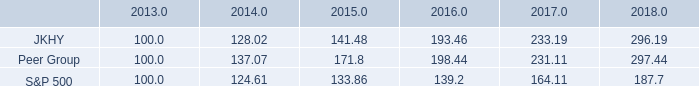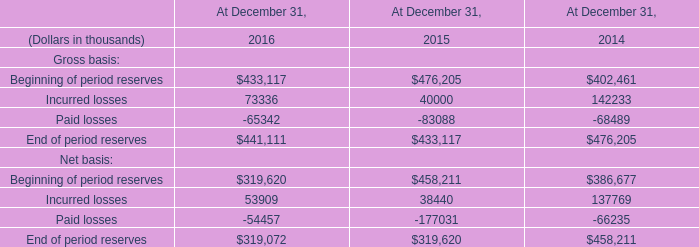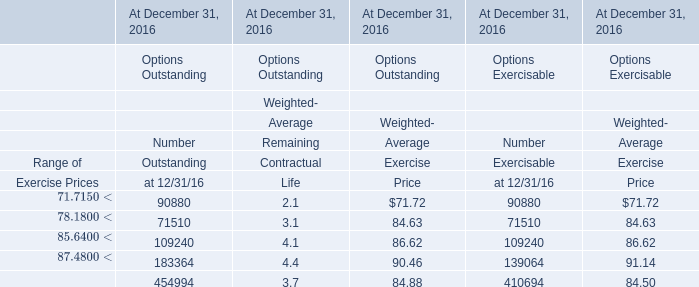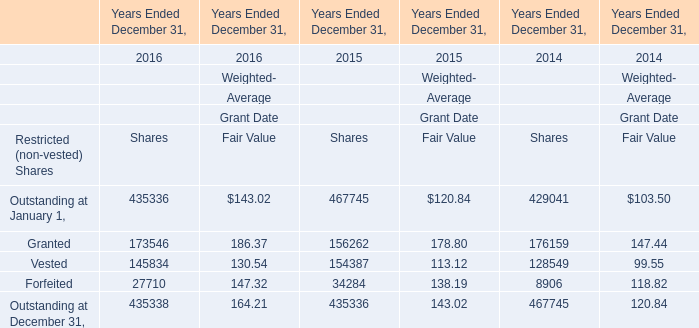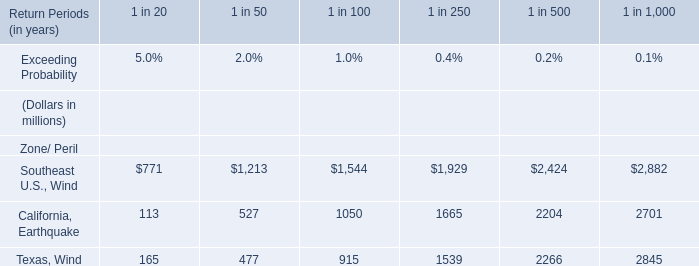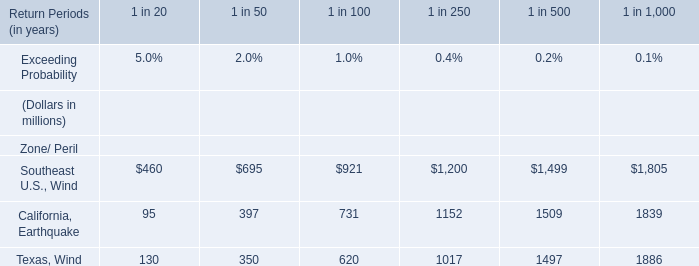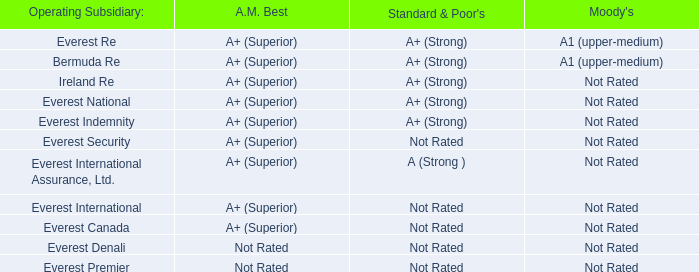What's the sum of all Shares that are greater than 100000 in 2016? 
Computations: (((173546 + 145834) + 435336) + 435338)
Answer: 1190054.0. 